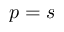Convert formula to latex. <formula><loc_0><loc_0><loc_500><loc_500>p = s</formula> 